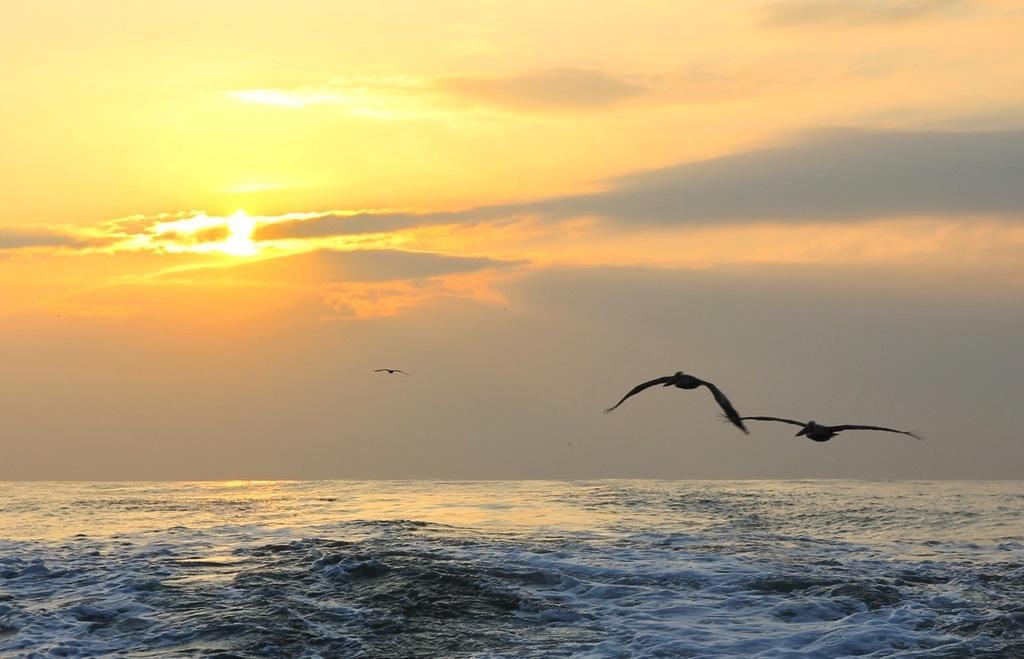How would you summarize this image in a sentence or two? In the image we can see water, cloudy sky and the sun. We can even see the birds flying. 